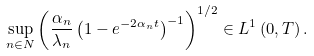Convert formula to latex. <formula><loc_0><loc_0><loc_500><loc_500>\sup _ { n \in N } \left ( \frac { \alpha _ { n } } { \lambda _ { n } } \left ( 1 - e ^ { - 2 \alpha _ { n } t } \right ) ^ { - 1 } \right ) ^ { 1 / 2 } \in L ^ { 1 } \left ( 0 , T \right ) .</formula> 